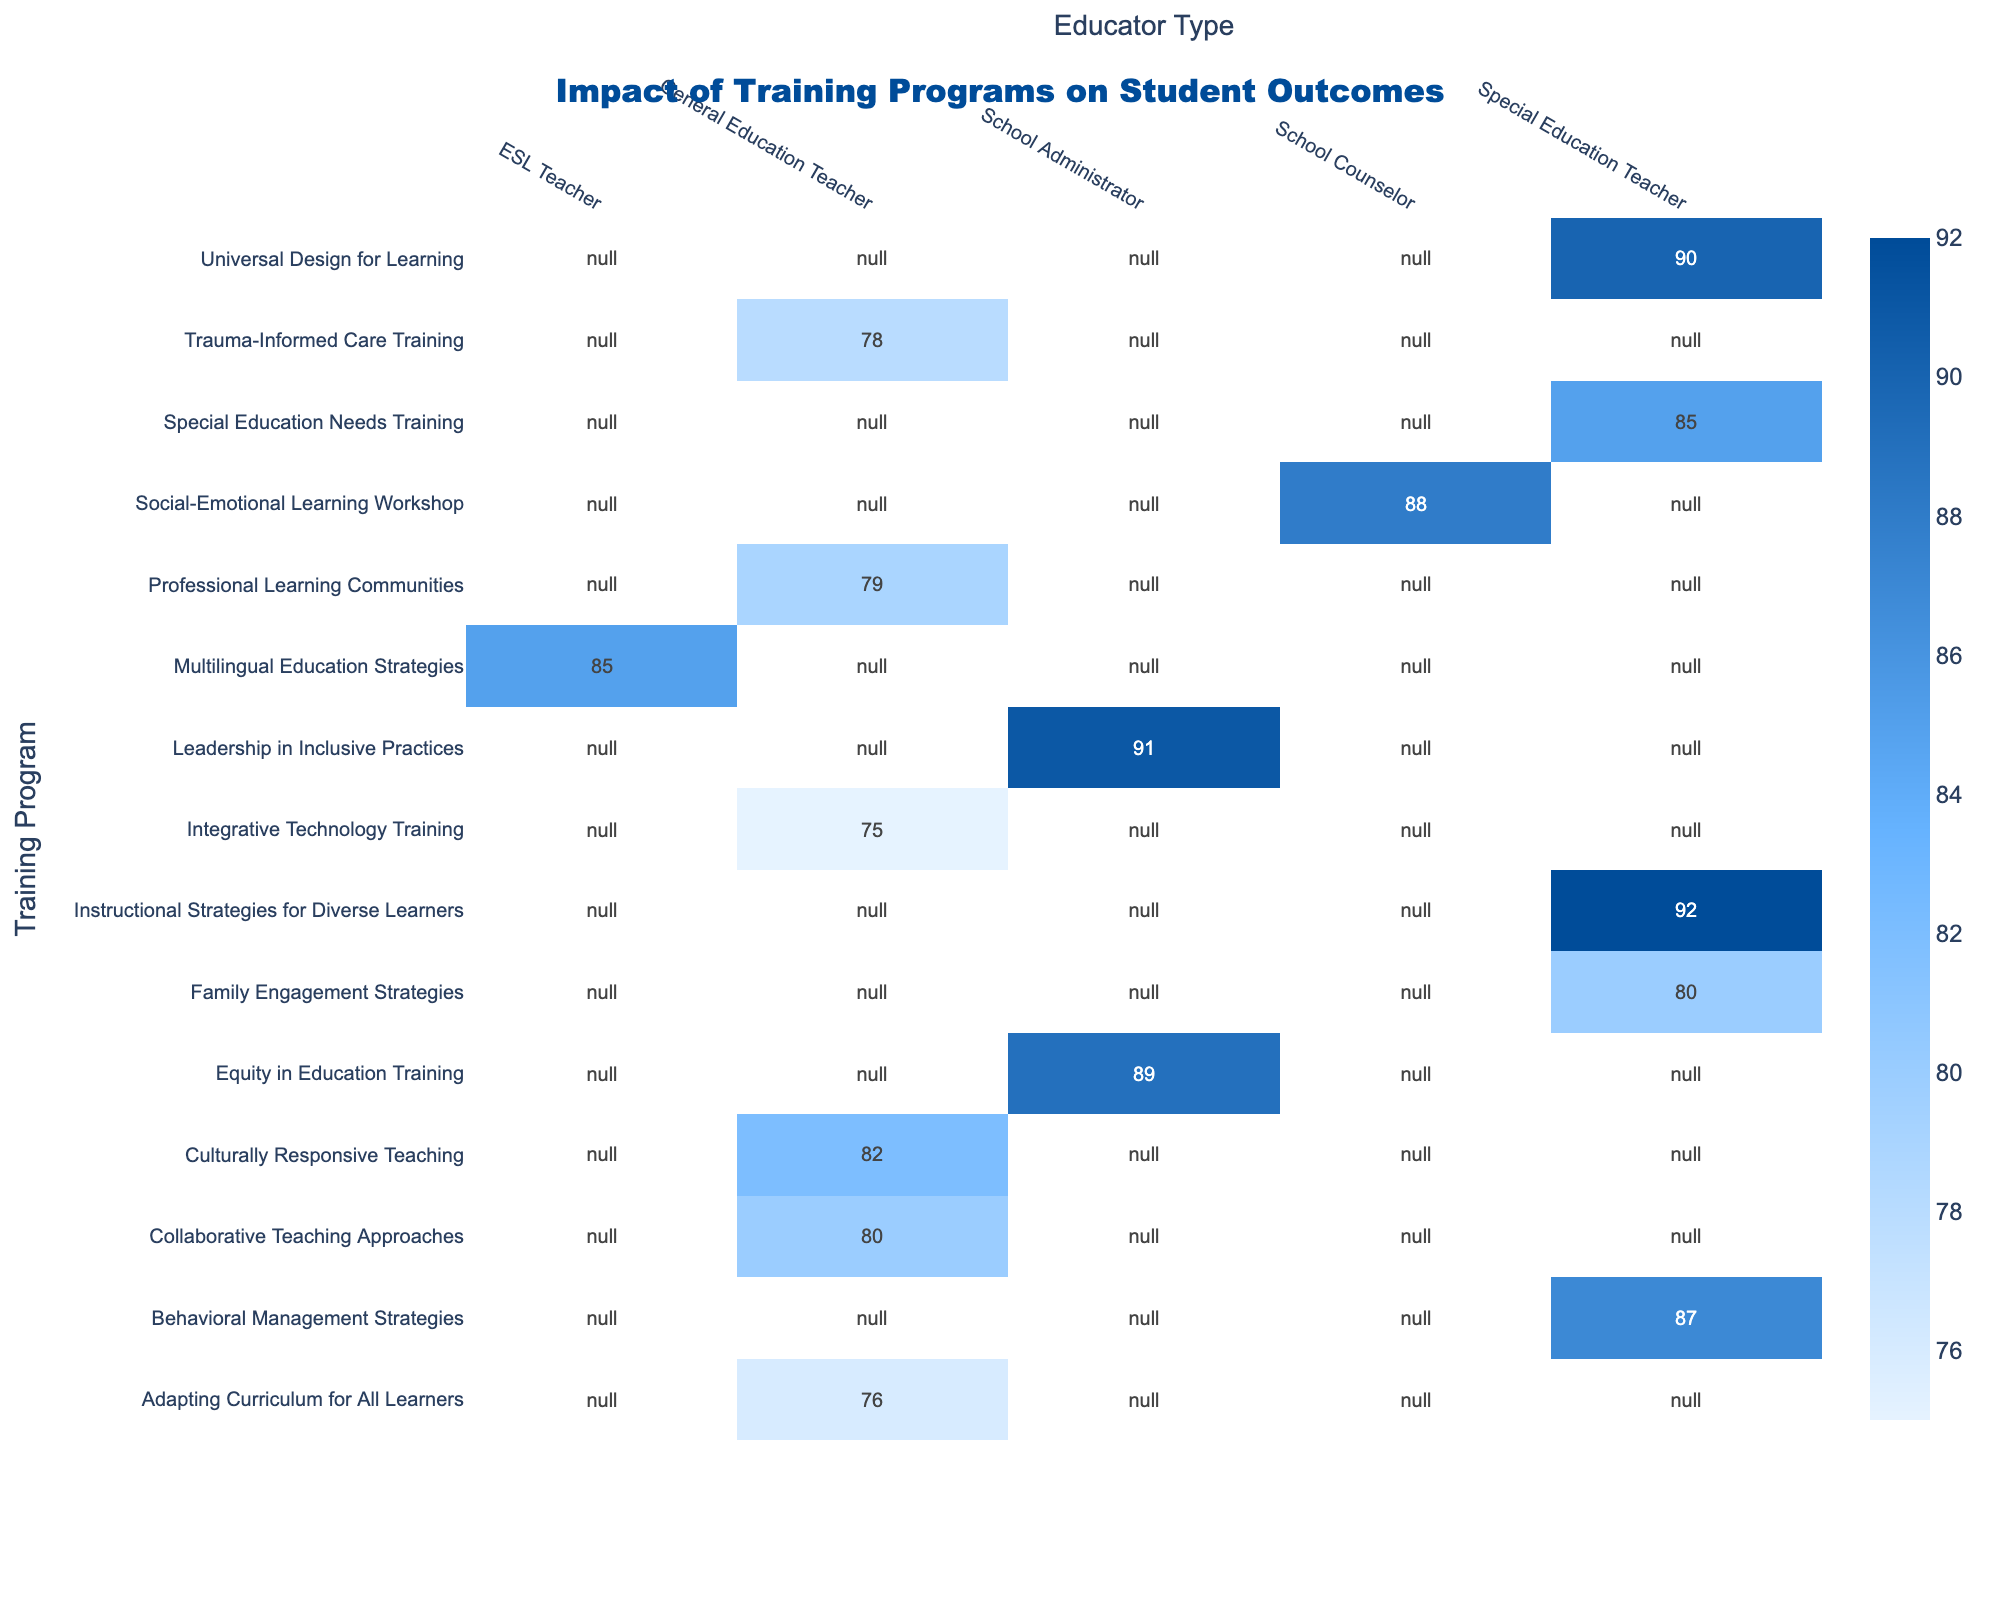What is the student outcome for the "Universal Design for Learning" training? The training program "Universal Design for Learning" is associated with the "Special Education Teacher" and has a student outcome value of 90.
Answer: 90 What training program has the highest student outcome rating among General Education Teachers? Looking at the table, the training program "Culturally Responsive Teaching" has the highest outcome rating of 82 for General Education Teachers.
Answer: 82 Is it true that School Administrators have attended a training program that resulted in a student outcome of 89 or higher? The table shows that the "Equity in Education Training" for School Administrators has an outcome of 89, which confirms that it is true.
Answer: Yes What is the average student outcome rating for "Special Education Needs Training" and "Behavioral Management Strategies"? The outcomes for "Special Education Needs Training" (85) and "Behavioral Management Strategies" (87) can be averaged. (85 + 87)/2 = 86.
Answer: 86 Which type of educator had the lowest average student outcome rating? To find this, I need to calculate average outcomes for each educator type: 
- Special Education Teachers: (85 + 90 + 92 + 87 + 80)/5 = 86.8
- General Education Teachers: (78 + 82 + 75 + 80 + 76 + 79)/6 = 77.33
- School Counselors: 88
- School Administrators: (89 + 91)/2 = 90
- ESL Teachers: 85 
The lowest average is 77.33 for General Education Teachers.
Answer: General Education Teachers What is the difference between the highest and lowest student outcome for Special Education Teachers? The highest outcome for Special Education Teachers is 92 (from "Instructional Strategies for Diverse Learners") and the lowest is 80 (from "Family Engagement Strategies"). The difference is 92 - 80 = 12.
Answer: 12 Which training program has the best impact on student outcomes for School Counselors? The "Social-Emotional Learning Workshop" shows the highest student outcome for School Counselors, with a rating of 88.
Answer: 88 Are all training programs attended by School Administrators resulting in student outcomes equal to or greater than 89? There are two trainings for School Administrators: "Equity in Education Training" (89) and "Leadership in Inclusive Practices" (91). Both are equal to or above 89, so the answer is yes.
Answer: Yes 